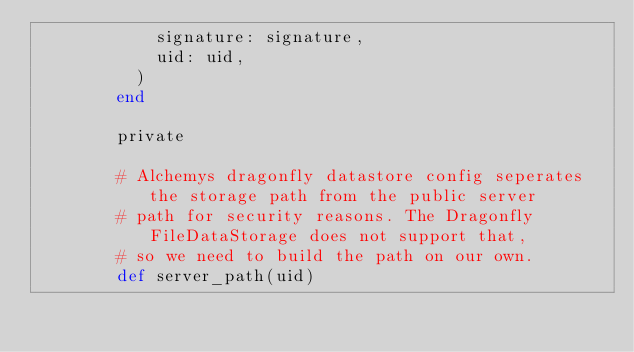<code> <loc_0><loc_0><loc_500><loc_500><_Ruby_>            signature: signature,
            uid: uid,
          )
        end

        private

        # Alchemys dragonfly datastore config seperates the storage path from the public server
        # path for security reasons. The Dragonfly FileDataStorage does not support that,
        # so we need to build the path on our own.
        def server_path(uid)</code> 